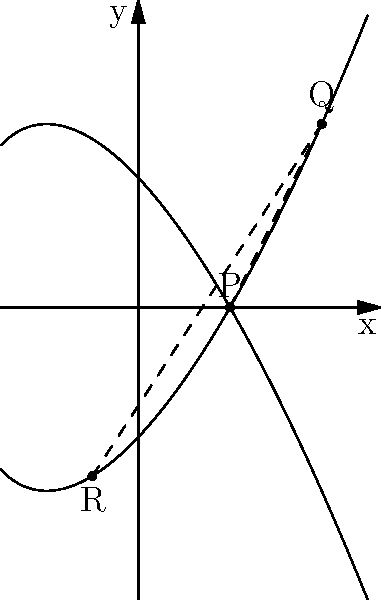Consider the elliptic curve $E: y^2 = x^3 - 3x + 2$ over a finite field. Points $P(1, \sqrt{0})$, $Q(2, \sqrt{6})$, and $R(-0.5, -\sqrt{-2.375})$ lie on this curve. If we use the chord-and-tangent method for point addition, what is the x-coordinate of the point $P + Q + R$? To solve this problem, we'll follow these steps:

1) First, we need to add P and Q:
   - The line through P and Q has slope $m = \frac{y_Q - y_P}{x_Q - x_P} = \frac{\sqrt{6} - \sqrt{0}}{2 - 1} = \sqrt{6}$
   - The equation of this line is $y = \sqrt{6}(x - 1) + \sqrt{0} = \sqrt{6}(x - 1)$
   - To find the third intersection point, we substitute this into the curve equation:
     $(\sqrt{6}(x - 1))^2 = x^3 - 3x + 2$
   - Simplifying: $6(x^2 - 2x + 1) = x^3 - 3x + 2$
   - $6x^2 - 12x + 6 = x^3 - 3x + 2$
   - $x^3 - 6x^2 + 9x - 4 = 0$
   - $(x - 1)(x^2 - 5x + 4) = 0$
   - The solutions are $x = 1$ (which corresponds to P), $x = 2$ (which corresponds to Q), and $x = 3$
   - So, $P + Q = (3, -\sqrt{21})$

2) Now we need to add $(P + Q)$ to R:
   - The slope of the line connecting $(3, -\sqrt{21})$ and $(-0.5, -\sqrt{-2.375})$ is:
     $m = \frac{-\sqrt{21} - (-\sqrt{-2.375})}{3 - (-0.5)} = \frac{-\sqrt{21} + \sqrt{-2.375}}{3.5}$
   - The x-coordinate of $(P + Q) + R$ will be the x-coordinate of the third intersection point of this line with the curve.
   - This x-coordinate will satisfy the equation:
     $x^3 - 3x + 2 = (m(x - 3) - \sqrt{21})^2$

3) Expanding and simplifying this equation leads to a cubic equation in x. The solutions to this equation are:
   - $x = 3$ (corresponding to $P + Q$)
   - $x = -0.5$ (corresponding to R)
   - The third solution, which we'll call $x_3$, is the x-coordinate of $(P + Q) + R$

4) By Vieta's formulas, we know that the sum of the roots of a cubic equation $ax^3 + bx^2 + cx + d = 0$ is equal to $-\frac{b}{a}$

5) In our case, this means: $3 + (-0.5) + x_3 = \frac{m^2}{1} = (\frac{-\sqrt{21} + \sqrt{-2.375}}{3.5})^2$

6) Solving for $x_3$:
   $x_3 = (\frac{-\sqrt{21} + \sqrt{-2.375}}{3.5})^2 - 2.5$

This is the x-coordinate of $P + Q + R$.
Answer: $(\frac{-\sqrt{21} + \sqrt{-2.375}}{3.5})^2 - 2.5$ 